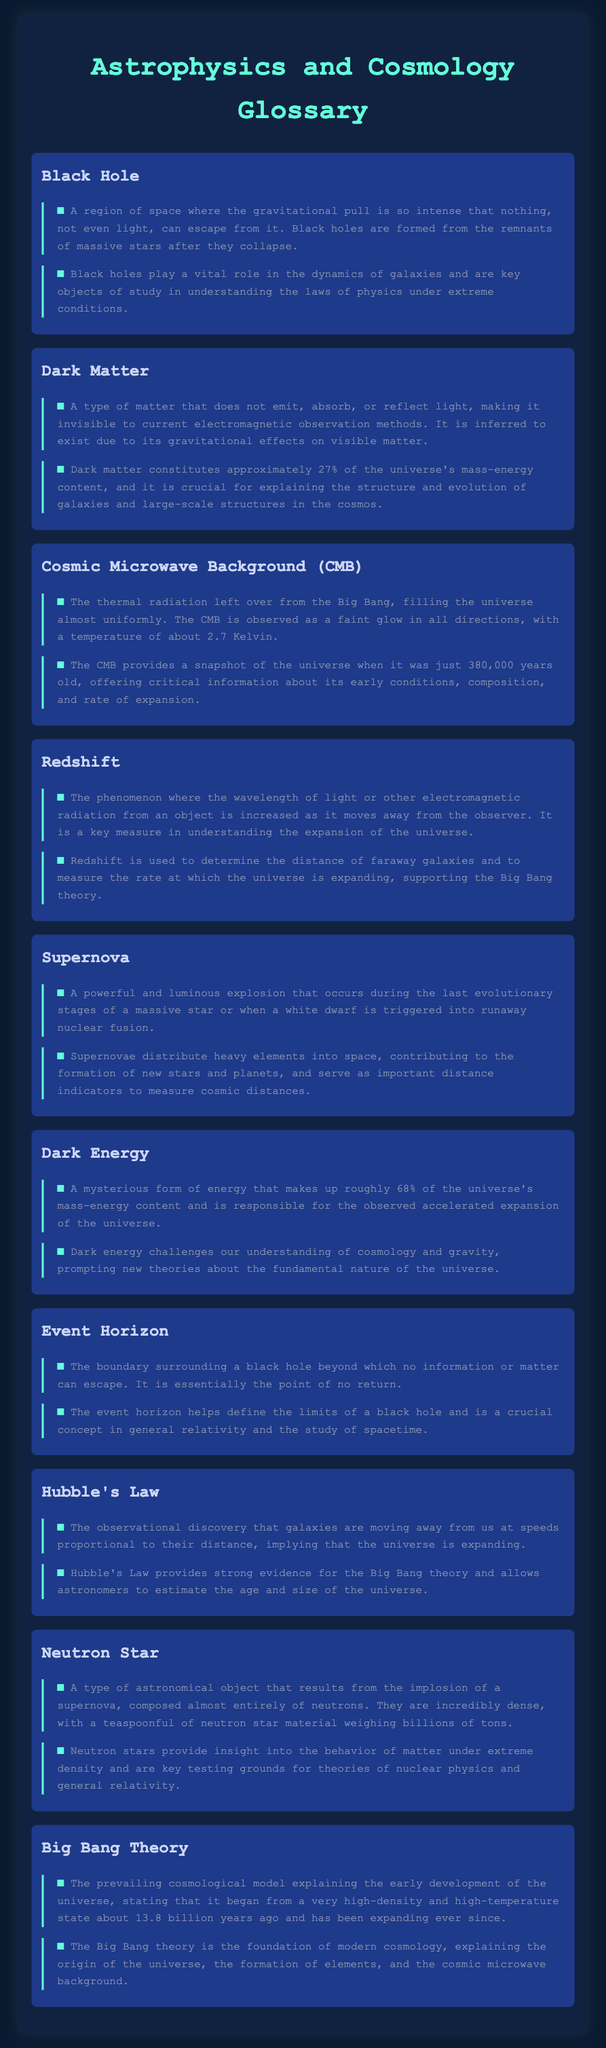What defines a black hole? A black hole is defined as a region of space where the gravitational pull is so intense that nothing, not even light, can escape from it.
Answer: A region of space where the gravitational pull is so intense that nothing, not even light, can escape from it What percentage of the universe's mass-energy content is dark matter? The document states that dark matter constitutes approximately 27% of the universe's mass-energy content.
Answer: Approximately 27% What temperature is associated with the cosmic microwave background? The temperature of the cosmic microwave background is noted to be about 2.7 Kelvin.
Answer: About 2.7 Kelvin What explosive event distributes heavy elements into space? The document mentions that supernovae are powerful explosions that distribute heavy elements into space.
Answer: Supernovae How does Hubble's Law contribute to our understanding of the universe? Hubble's Law provides strong evidence for the Big Bang theory and allows astronomers to estimate the age and size of the universe.
Answer: Provides strong evidence for the Big Bang theory What is the boundary around a black hole called? The boundary surrounding a black hole, beyond which no information or matter can escape, is called the event horizon.
Answer: Event horizon Why is dark energy significant in cosmology? Dark energy is significant because it makes up roughly 68% of the universe's mass-energy content and is responsible for the observed accelerated expansion of the universe.
Answer: Responsible for the observed accelerated expansion of the universe What process leads to the formation of neutron stars? Neutron stars result from the implosion of a supernova.
Answer: Implosion of a supernova What is the primary concept that the Big Bang theory explains? The Big Bang theory mainly explains the origin of the universe, including its expansion from a very high-density and high-temperature state.
Answer: The origin of the universe 